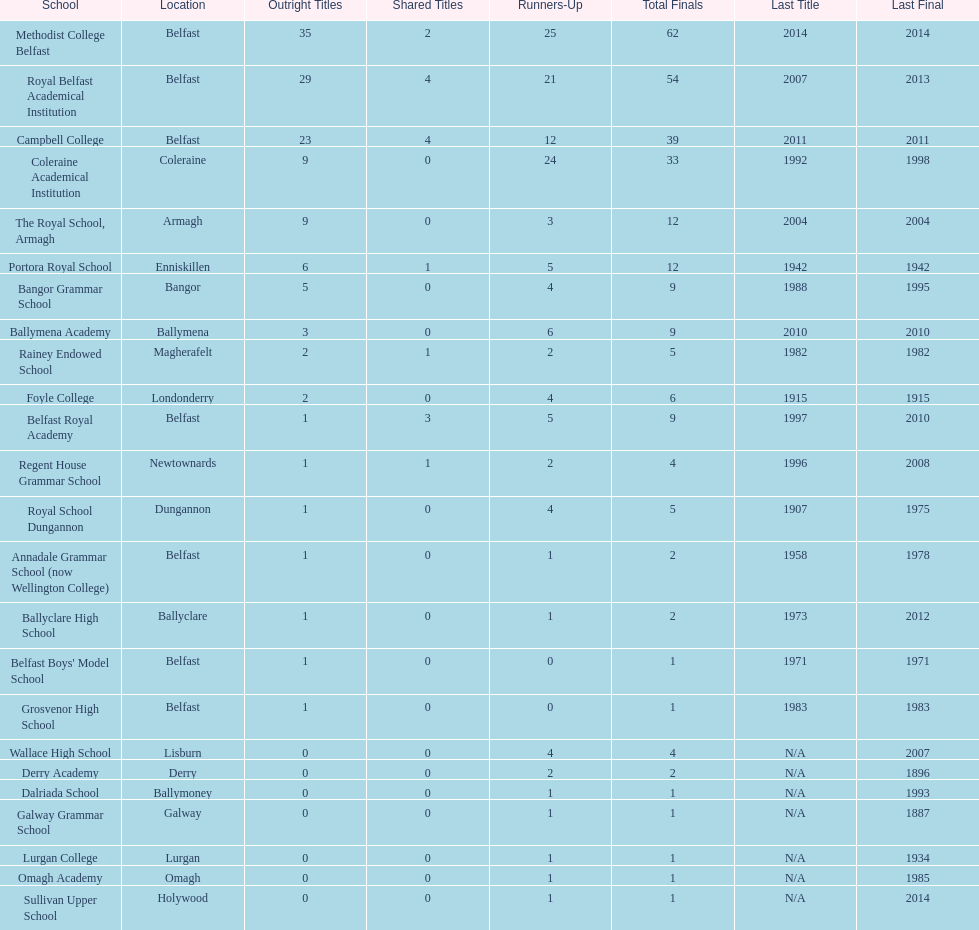How many schools have at least 5 outright titles? 7. 